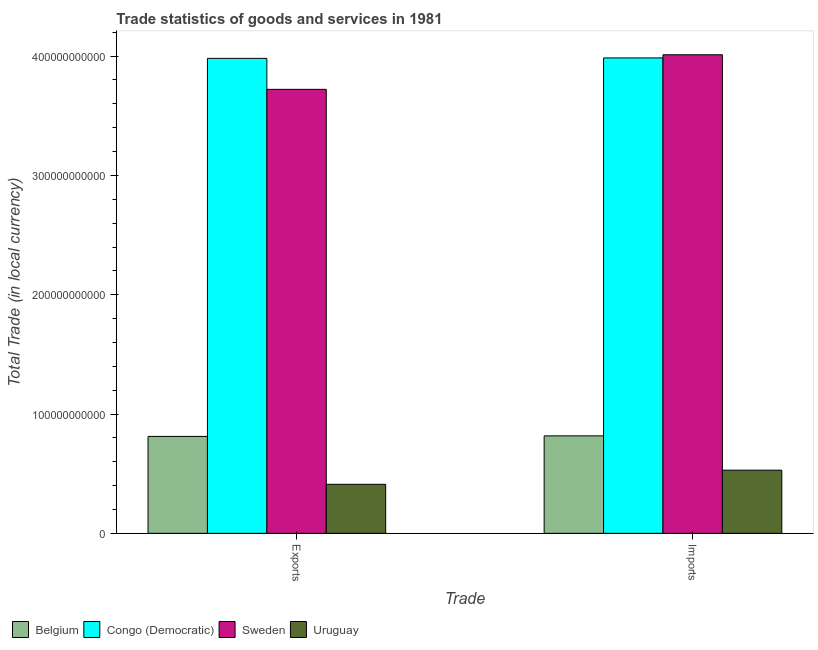Are the number of bars per tick equal to the number of legend labels?
Your response must be concise. Yes. Are the number of bars on each tick of the X-axis equal?
Give a very brief answer. Yes. How many bars are there on the 2nd tick from the left?
Provide a succinct answer. 4. What is the label of the 1st group of bars from the left?
Provide a short and direct response. Exports. What is the export of goods and services in Congo (Democratic)?
Provide a succinct answer. 3.98e+11. Across all countries, what is the maximum imports of goods and services?
Make the answer very short. 4.01e+11. Across all countries, what is the minimum imports of goods and services?
Offer a very short reply. 5.29e+1. In which country was the imports of goods and services minimum?
Provide a succinct answer. Uruguay. What is the total imports of goods and services in the graph?
Provide a short and direct response. 9.34e+11. What is the difference between the imports of goods and services in Uruguay and that in Sweden?
Provide a succinct answer. -3.48e+11. What is the difference between the imports of goods and services in Belgium and the export of goods and services in Uruguay?
Offer a terse response. 4.06e+1. What is the average export of goods and services per country?
Your response must be concise. 2.23e+11. What is the difference between the export of goods and services and imports of goods and services in Congo (Democratic)?
Keep it short and to the point. -3.73e+08. What is the ratio of the export of goods and services in Congo (Democratic) to that in Uruguay?
Your response must be concise. 9.69. In how many countries, is the export of goods and services greater than the average export of goods and services taken over all countries?
Keep it short and to the point. 2. What does the 2nd bar from the left in Exports represents?
Offer a terse response. Congo (Democratic). What does the 2nd bar from the right in Exports represents?
Offer a terse response. Sweden. How many bars are there?
Make the answer very short. 8. Are all the bars in the graph horizontal?
Provide a succinct answer. No. How many countries are there in the graph?
Keep it short and to the point. 4. What is the difference between two consecutive major ticks on the Y-axis?
Your response must be concise. 1.00e+11. Does the graph contain grids?
Offer a terse response. No. Where does the legend appear in the graph?
Provide a short and direct response. Bottom left. What is the title of the graph?
Offer a terse response. Trade statistics of goods and services in 1981. Does "El Salvador" appear as one of the legend labels in the graph?
Your response must be concise. No. What is the label or title of the X-axis?
Make the answer very short. Trade. What is the label or title of the Y-axis?
Keep it short and to the point. Total Trade (in local currency). What is the Total Trade (in local currency) in Belgium in Exports?
Give a very brief answer. 8.12e+1. What is the Total Trade (in local currency) of Congo (Democratic) in Exports?
Ensure brevity in your answer.  3.98e+11. What is the Total Trade (in local currency) in Sweden in Exports?
Ensure brevity in your answer.  3.72e+11. What is the Total Trade (in local currency) in Uruguay in Exports?
Your answer should be compact. 4.11e+1. What is the Total Trade (in local currency) in Belgium in Imports?
Your answer should be compact. 8.17e+1. What is the Total Trade (in local currency) in Congo (Democratic) in Imports?
Offer a very short reply. 3.98e+11. What is the Total Trade (in local currency) in Sweden in Imports?
Provide a short and direct response. 4.01e+11. What is the Total Trade (in local currency) of Uruguay in Imports?
Provide a short and direct response. 5.29e+1. Across all Trade, what is the maximum Total Trade (in local currency) of Belgium?
Offer a terse response. 8.17e+1. Across all Trade, what is the maximum Total Trade (in local currency) of Congo (Democratic)?
Offer a very short reply. 3.98e+11. Across all Trade, what is the maximum Total Trade (in local currency) of Sweden?
Offer a terse response. 4.01e+11. Across all Trade, what is the maximum Total Trade (in local currency) of Uruguay?
Make the answer very short. 5.29e+1. Across all Trade, what is the minimum Total Trade (in local currency) of Belgium?
Your answer should be compact. 8.12e+1. Across all Trade, what is the minimum Total Trade (in local currency) of Congo (Democratic)?
Give a very brief answer. 3.98e+11. Across all Trade, what is the minimum Total Trade (in local currency) in Sweden?
Ensure brevity in your answer.  3.72e+11. Across all Trade, what is the minimum Total Trade (in local currency) in Uruguay?
Your answer should be compact. 4.11e+1. What is the total Total Trade (in local currency) of Belgium in the graph?
Offer a very short reply. 1.63e+11. What is the total Total Trade (in local currency) in Congo (Democratic) in the graph?
Offer a terse response. 7.97e+11. What is the total Total Trade (in local currency) of Sweden in the graph?
Your answer should be very brief. 7.73e+11. What is the total Total Trade (in local currency) in Uruguay in the graph?
Provide a succinct answer. 9.40e+1. What is the difference between the Total Trade (in local currency) of Belgium in Exports and that in Imports?
Provide a short and direct response. -4.58e+08. What is the difference between the Total Trade (in local currency) in Congo (Democratic) in Exports and that in Imports?
Offer a terse response. -3.73e+08. What is the difference between the Total Trade (in local currency) in Sweden in Exports and that in Imports?
Offer a very short reply. -2.90e+1. What is the difference between the Total Trade (in local currency) in Uruguay in Exports and that in Imports?
Keep it short and to the point. -1.18e+1. What is the difference between the Total Trade (in local currency) of Belgium in Exports and the Total Trade (in local currency) of Congo (Democratic) in Imports?
Offer a terse response. -3.17e+11. What is the difference between the Total Trade (in local currency) of Belgium in Exports and the Total Trade (in local currency) of Sweden in Imports?
Keep it short and to the point. -3.20e+11. What is the difference between the Total Trade (in local currency) of Belgium in Exports and the Total Trade (in local currency) of Uruguay in Imports?
Your answer should be compact. 2.83e+1. What is the difference between the Total Trade (in local currency) in Congo (Democratic) in Exports and the Total Trade (in local currency) in Sweden in Imports?
Keep it short and to the point. -3.03e+09. What is the difference between the Total Trade (in local currency) of Congo (Democratic) in Exports and the Total Trade (in local currency) of Uruguay in Imports?
Make the answer very short. 3.45e+11. What is the difference between the Total Trade (in local currency) in Sweden in Exports and the Total Trade (in local currency) in Uruguay in Imports?
Your response must be concise. 3.19e+11. What is the average Total Trade (in local currency) of Belgium per Trade?
Provide a short and direct response. 8.15e+1. What is the average Total Trade (in local currency) in Congo (Democratic) per Trade?
Your answer should be compact. 3.98e+11. What is the average Total Trade (in local currency) in Sweden per Trade?
Offer a terse response. 3.87e+11. What is the average Total Trade (in local currency) of Uruguay per Trade?
Make the answer very short. 4.70e+1. What is the difference between the Total Trade (in local currency) in Belgium and Total Trade (in local currency) in Congo (Democratic) in Exports?
Your answer should be very brief. -3.17e+11. What is the difference between the Total Trade (in local currency) in Belgium and Total Trade (in local currency) in Sweden in Exports?
Give a very brief answer. -2.91e+11. What is the difference between the Total Trade (in local currency) in Belgium and Total Trade (in local currency) in Uruguay in Exports?
Offer a terse response. 4.01e+1. What is the difference between the Total Trade (in local currency) in Congo (Democratic) and Total Trade (in local currency) in Sweden in Exports?
Make the answer very short. 2.60e+1. What is the difference between the Total Trade (in local currency) of Congo (Democratic) and Total Trade (in local currency) of Uruguay in Exports?
Keep it short and to the point. 3.57e+11. What is the difference between the Total Trade (in local currency) in Sweden and Total Trade (in local currency) in Uruguay in Exports?
Provide a succinct answer. 3.31e+11. What is the difference between the Total Trade (in local currency) of Belgium and Total Trade (in local currency) of Congo (Democratic) in Imports?
Give a very brief answer. -3.17e+11. What is the difference between the Total Trade (in local currency) in Belgium and Total Trade (in local currency) in Sweden in Imports?
Your answer should be compact. -3.19e+11. What is the difference between the Total Trade (in local currency) of Belgium and Total Trade (in local currency) of Uruguay in Imports?
Provide a short and direct response. 2.88e+1. What is the difference between the Total Trade (in local currency) in Congo (Democratic) and Total Trade (in local currency) in Sweden in Imports?
Your response must be concise. -2.65e+09. What is the difference between the Total Trade (in local currency) in Congo (Democratic) and Total Trade (in local currency) in Uruguay in Imports?
Make the answer very short. 3.46e+11. What is the difference between the Total Trade (in local currency) of Sweden and Total Trade (in local currency) of Uruguay in Imports?
Your answer should be compact. 3.48e+11. What is the ratio of the Total Trade (in local currency) of Congo (Democratic) in Exports to that in Imports?
Your answer should be compact. 1. What is the ratio of the Total Trade (in local currency) in Sweden in Exports to that in Imports?
Offer a very short reply. 0.93. What is the ratio of the Total Trade (in local currency) in Uruguay in Exports to that in Imports?
Your answer should be compact. 0.78. What is the difference between the highest and the second highest Total Trade (in local currency) in Belgium?
Offer a very short reply. 4.58e+08. What is the difference between the highest and the second highest Total Trade (in local currency) of Congo (Democratic)?
Ensure brevity in your answer.  3.73e+08. What is the difference between the highest and the second highest Total Trade (in local currency) in Sweden?
Make the answer very short. 2.90e+1. What is the difference between the highest and the second highest Total Trade (in local currency) in Uruguay?
Make the answer very short. 1.18e+1. What is the difference between the highest and the lowest Total Trade (in local currency) of Belgium?
Offer a terse response. 4.58e+08. What is the difference between the highest and the lowest Total Trade (in local currency) in Congo (Democratic)?
Provide a succinct answer. 3.73e+08. What is the difference between the highest and the lowest Total Trade (in local currency) of Sweden?
Your answer should be compact. 2.90e+1. What is the difference between the highest and the lowest Total Trade (in local currency) in Uruguay?
Your answer should be very brief. 1.18e+1. 